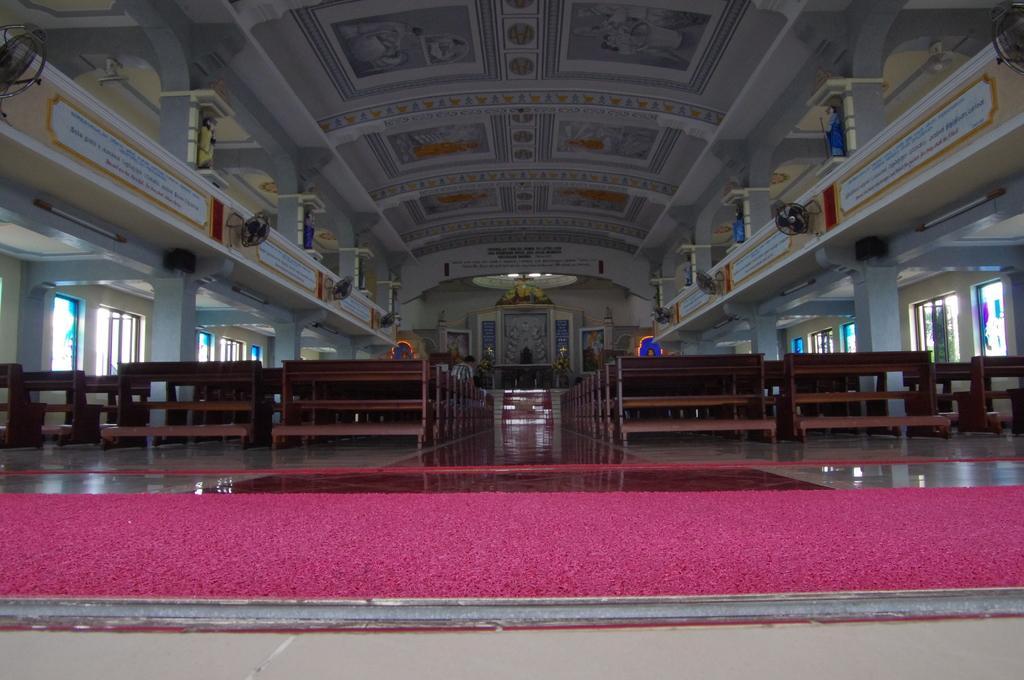How would you summarize this image in a sentence or two? In this image in the center there are benches and on the left side of the wall there are fans and there is some text written on the wall. On the right side of the wall there are fans and there is some text written on the wall. In the front on the floor there is a mat. 